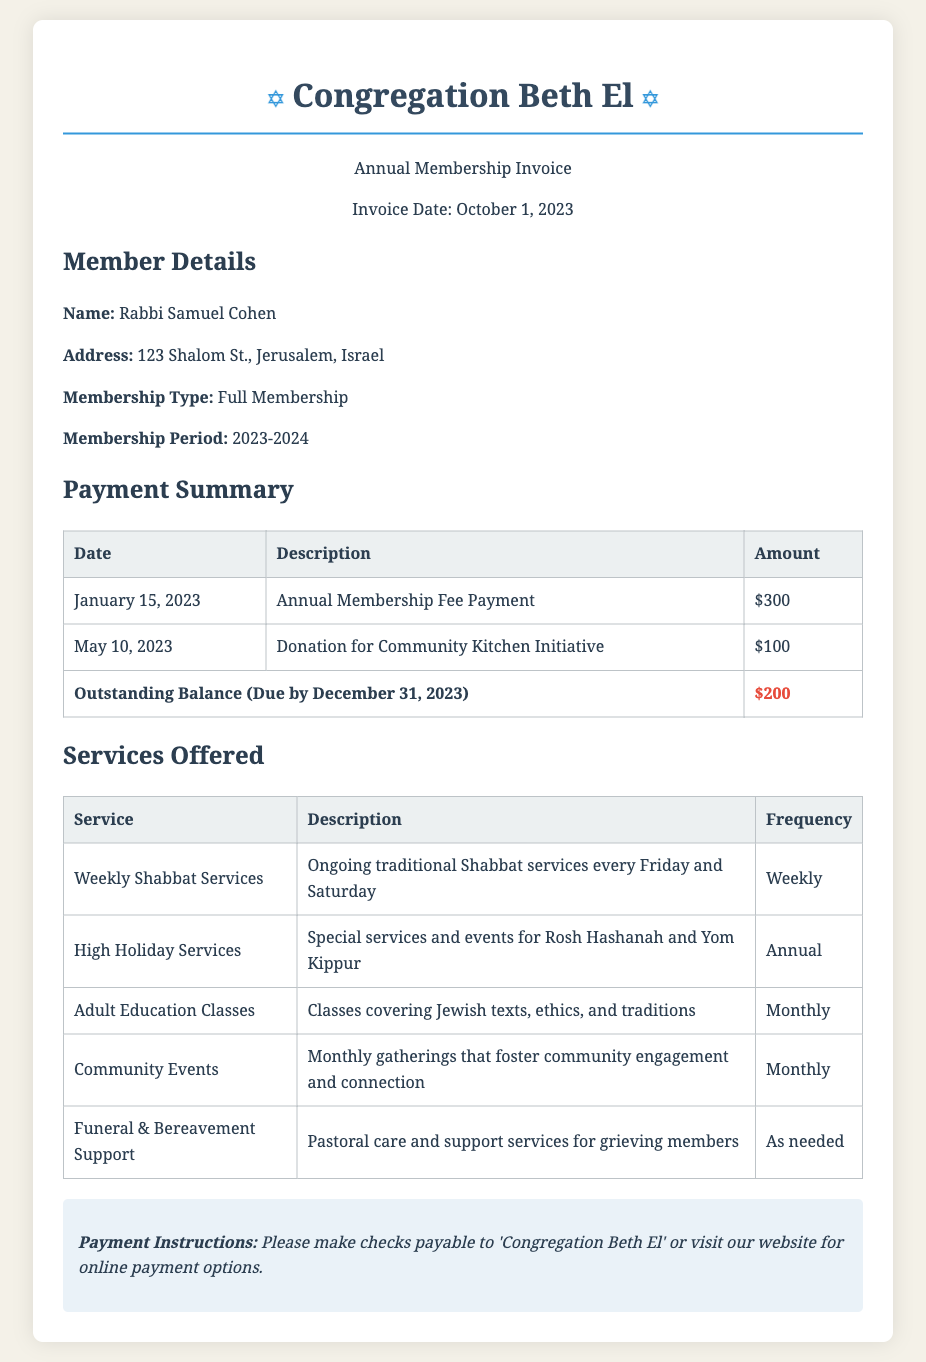What is the name of the member? The document lists the member's name as Rabbi Samuel Cohen.
Answer: Rabbi Samuel Cohen What is the address of the member? The member's address is provided in the document, listed as 123 Shalom St., Jerusalem, Israel.
Answer: 123 Shalom St., Jerusalem, Israel What is the total amount paid so far? The total paid amount can be calculated by adding the annual membership fee and the donation, which is $300 + $100.
Answer: $400 What is the outstanding balance? The outstanding balance is explicitly mentioned in the payment summary section as $200.
Answer: $200 What payment is due by December 31, 2023? The document indicates that the outstanding balance is due by December 31, 2023.
Answer: Outstanding Balance Which service is offered weekly? The document states that Weekly Shabbat Services are provided ongoing every Friday and Saturday.
Answer: Weekly Shabbat Services How often are Adult Education Classes held? The frequency of Adult Education Classes is stated as monthly in the document.
Answer: Monthly What is one of the services provided for grieving members? The document lists Funeral & Bereavement Support as a service offered for grieving members.
Answer: Funeral & Bereavement Support What payment method is suggested in the payment instructions? The document suggests making checks payable to 'Congregation Beth El' or visiting the website for online payment options.
Answer: Checks or online payment What is the membership type of Rabbi Samuel Cohen? The document clearly states that Rabbi Samuel Cohen holds a Full Membership type.
Answer: Full Membership 